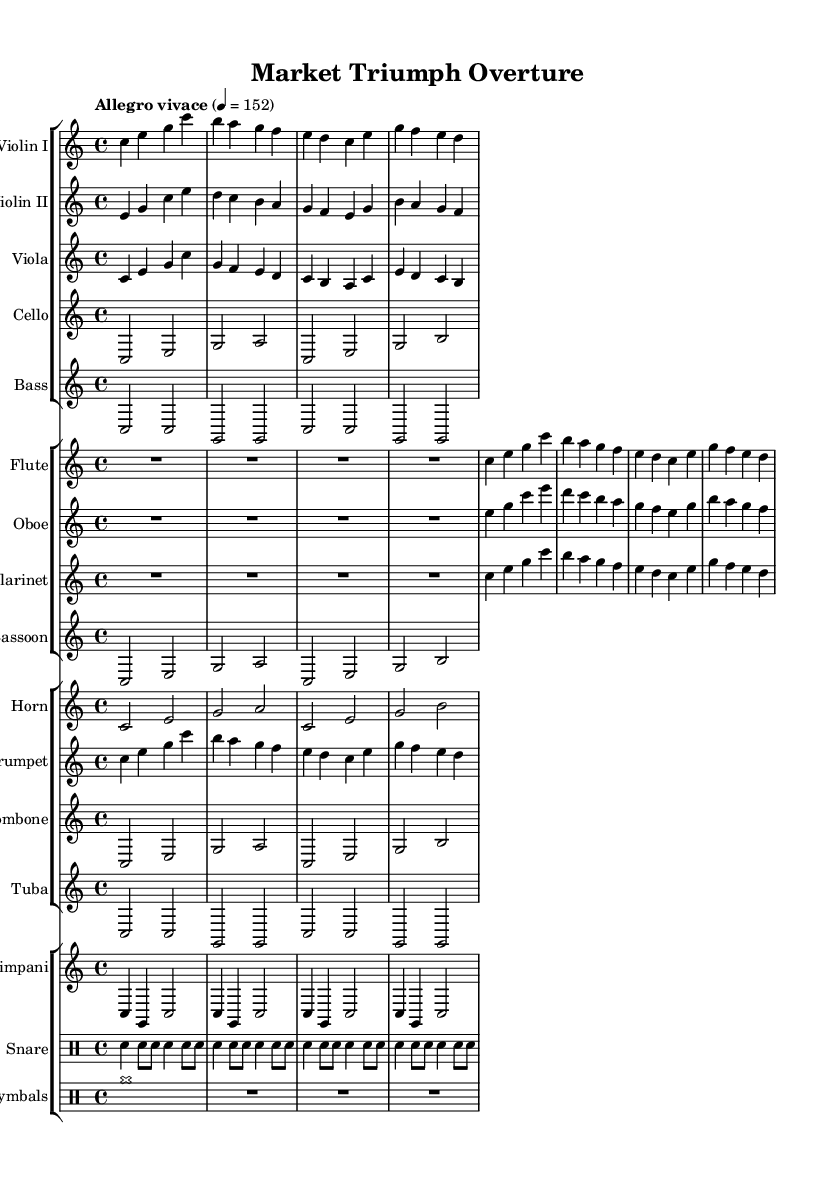What is the key signature of this music? The key signature is C major, which has no sharps or flats.
Answer: C major What is the time signature of this symphony? The time signature is indicated at the beginning of the score, which shows it is set to 4/4 time.
Answer: 4/4 What is the tempo marking for this piece? The tempo marking is indicated in the score, stating "Allegro vivace," which suggests a lively and fast tempo.
Answer: Allegro vivace Which instruments are playing the melody in the first four measures? Analyzing the first four measures, the melody is mainly carried by the violins and flutes, indicated by their prominent notes.
Answer: Violins and Flutes How many measures are there in the entire symphony? Counting all sections visually, the total number of measures is determined to be 16 measures in this musical excerpt, as seen across the staves.
Answer: 16 measures What is the lowest instrument in this symphony? The lowest instrument is the tuba, as it is written in the bass clef and produces the lowest pitch compared to other instruments present.
Answer: Tuba Which woodwind instrument plays the same notes as the trumpet in the first page? By comparing the melodies, the clarinet plays the same notes as the trumpet, particularly in the first few measures.
Answer: Clarinet 